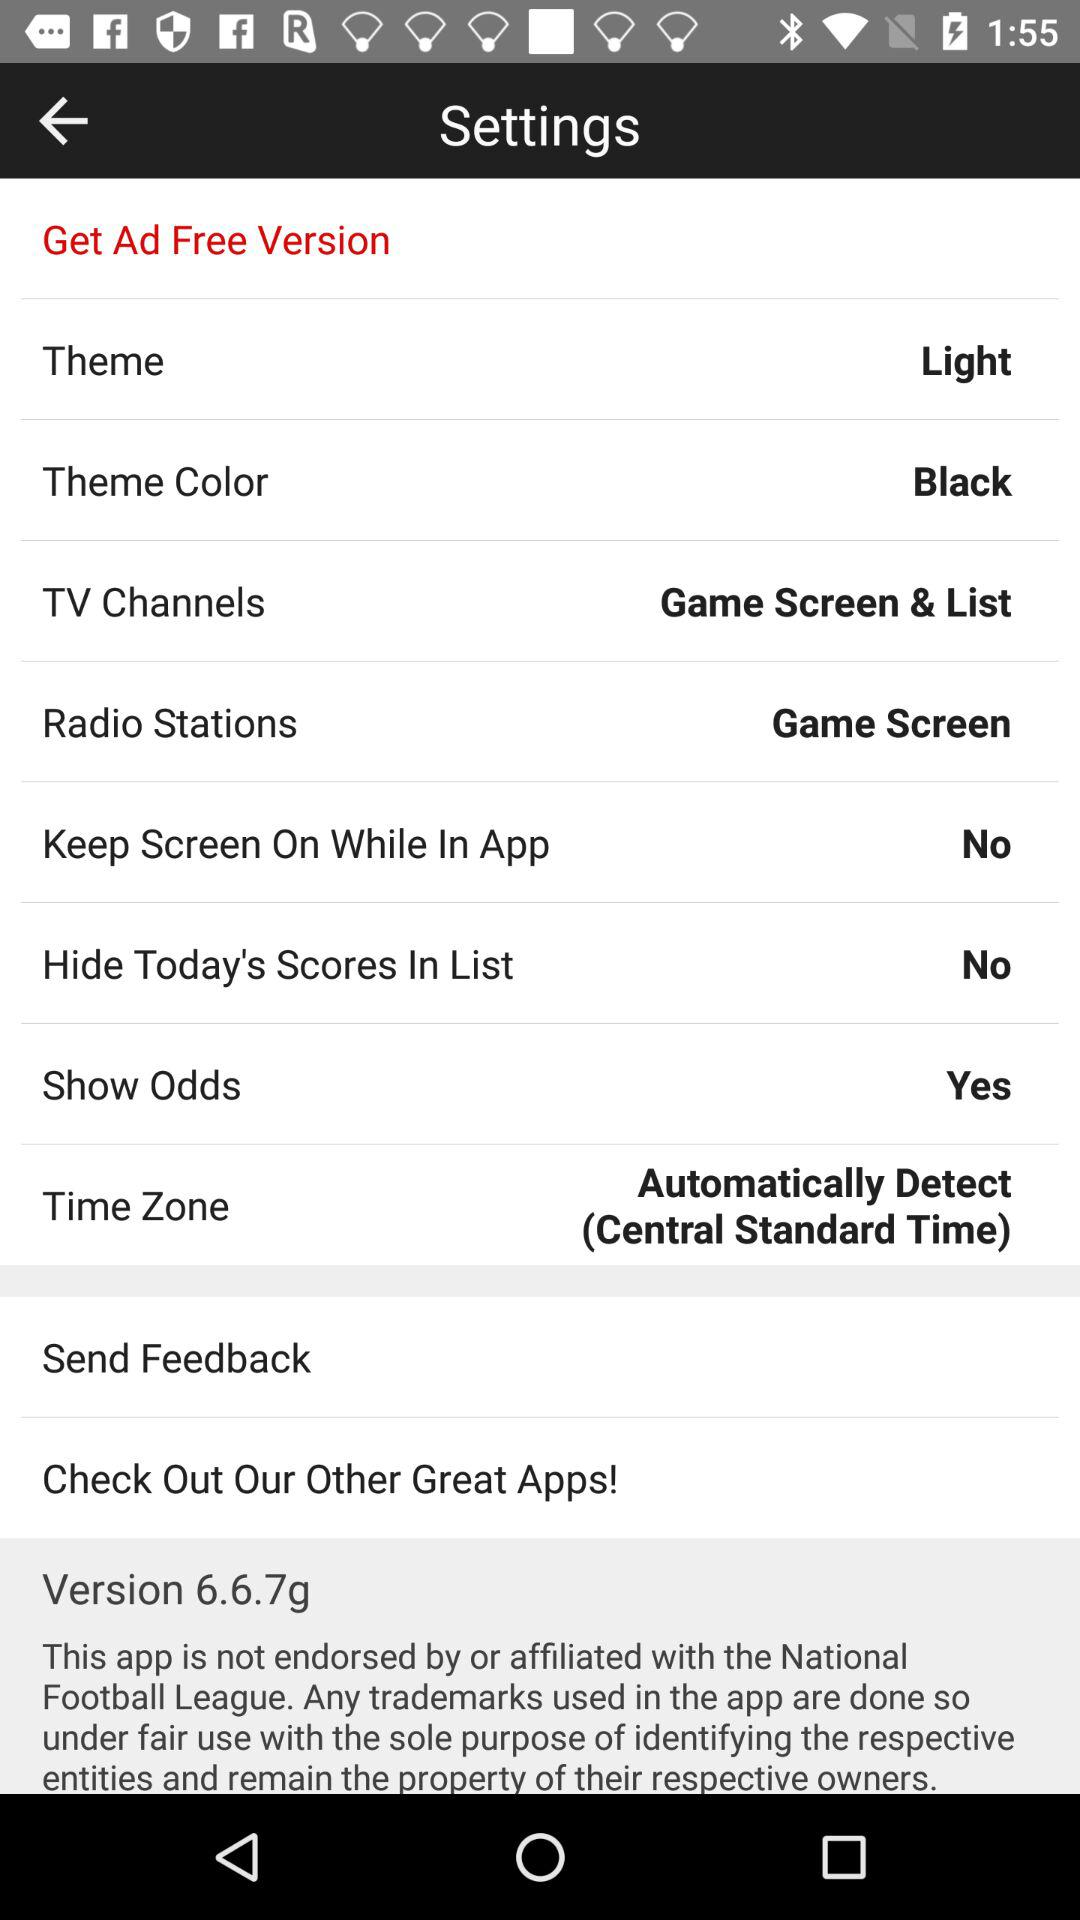What is the selected theme? The selected theme is "Light". 